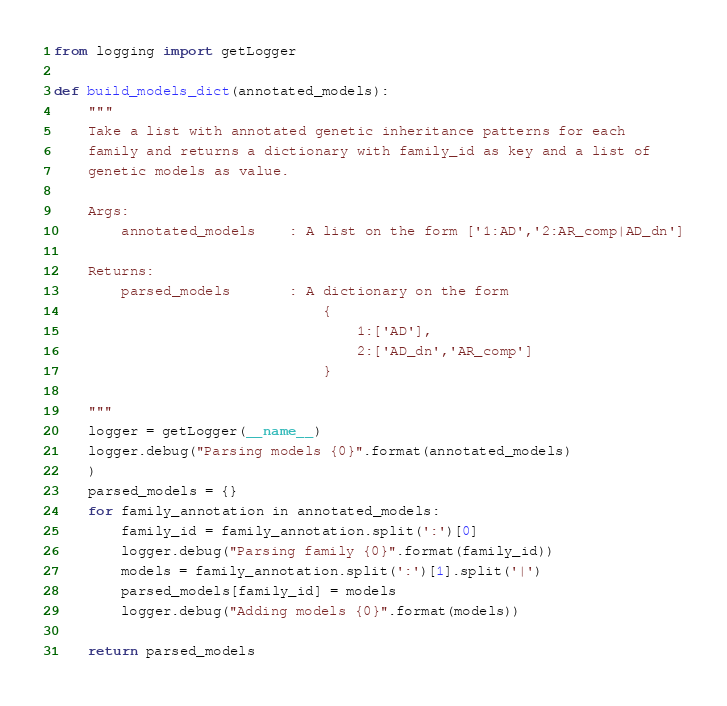<code> <loc_0><loc_0><loc_500><loc_500><_Python_>from logging import getLogger

def build_models_dict(annotated_models):
    """
    Take a list with annotated genetic inheritance patterns for each
    family and returns a dictionary with family_id as key and a list of
    genetic models as value.
    
    Args:
        annotated_models    : A list on the form ['1:AD','2:AR_comp|AD_dn']
    
    Returns:
        parsed_models       : A dictionary on the form
                                {
                                    1:['AD'],
                                    2:['AD_dn','AR_comp']
                                }
    
    """
    logger = getLogger(__name__)
    logger.debug("Parsing models {0}".format(annotated_models)
    )
    parsed_models = {}
    for family_annotation in annotated_models:
        family_id = family_annotation.split(':')[0]
        logger.debug("Parsing family {0}".format(family_id))
        models = family_annotation.split(':')[1].split('|')
        parsed_models[family_id] = models
        logger.debug("Adding models {0}".format(models))
    
    return parsed_models
</code> 